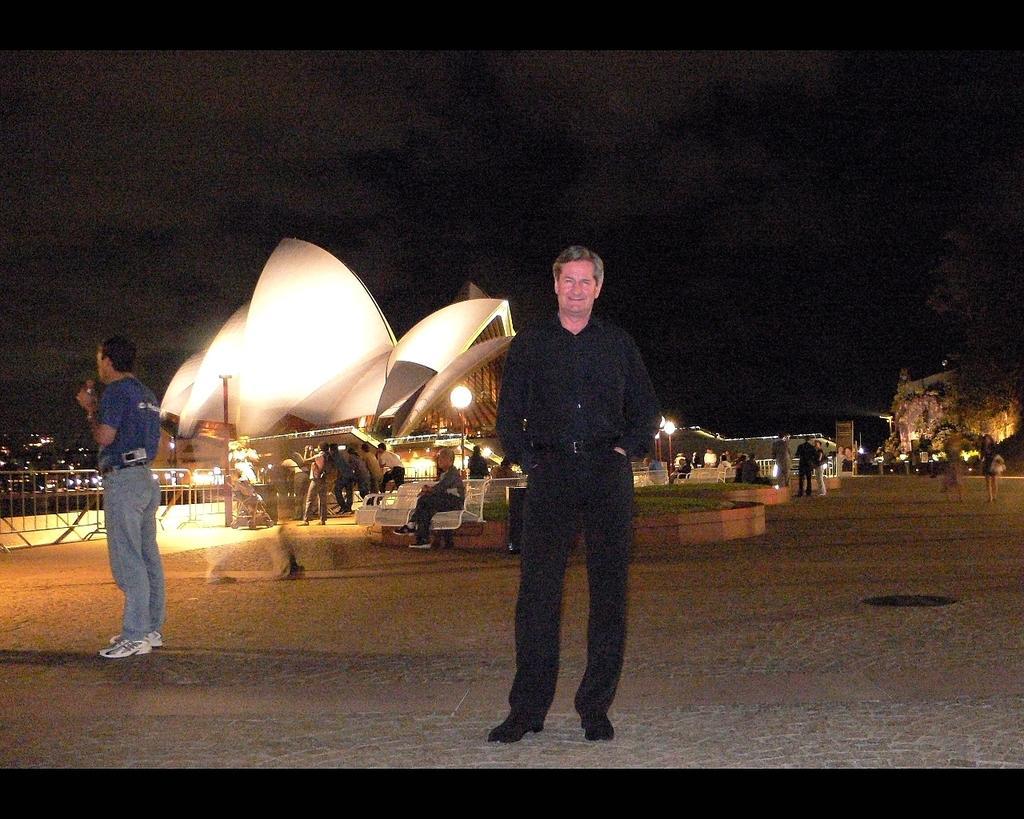In one or two sentences, can you explain what this image depicts? In this image I can see a person standing in the center. He is wearing a black dress. Another person is standing on the left. There is a fence on the left and a building at the back. There are lights and people are present at the back. There is a tree on the right. It's the nighttime. 